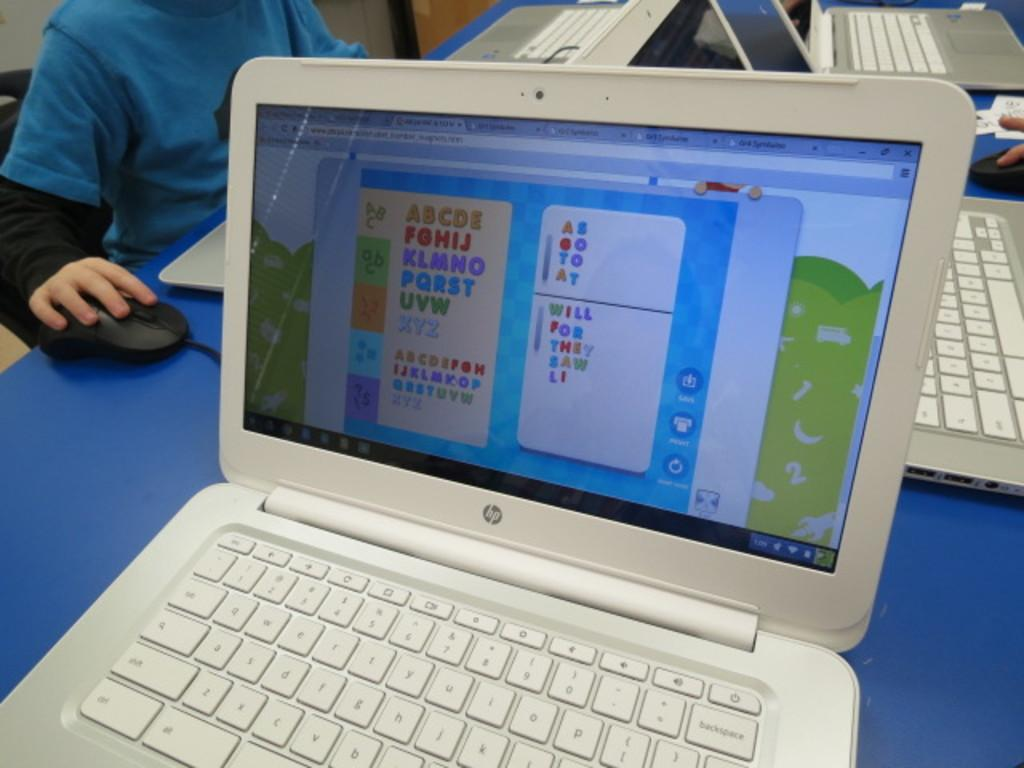<image>
Offer a succinct explanation of the picture presented. White laptop sitting on a table that has alphabet letters ABCDE in yellow. 